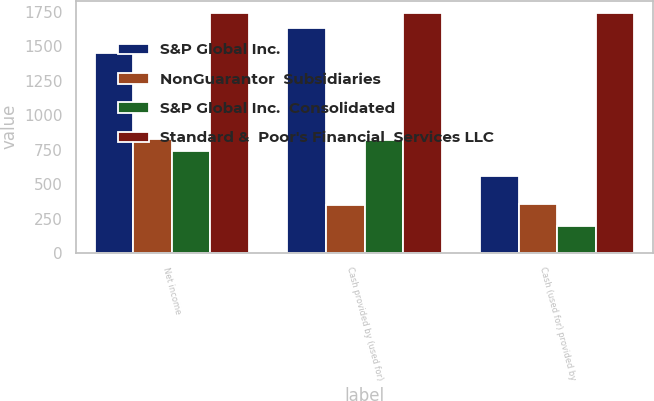Convert chart to OTSL. <chart><loc_0><loc_0><loc_500><loc_500><stacked_bar_chart><ecel><fcel>Net income<fcel>Cash provided by (used for)<fcel>Cash (used for) provided by<nl><fcel>S&P Global Inc.<fcel>1449<fcel>1632<fcel>557<nl><fcel>NonGuarantor  Subsidiaries<fcel>824<fcel>349<fcel>359<nl><fcel>S&P Global Inc.  Consolidated<fcel>740<fcel>818<fcel>198<nl><fcel>Standard &  Poor's Financial  Services LLC<fcel>1745<fcel>1745<fcel>1745<nl></chart> 